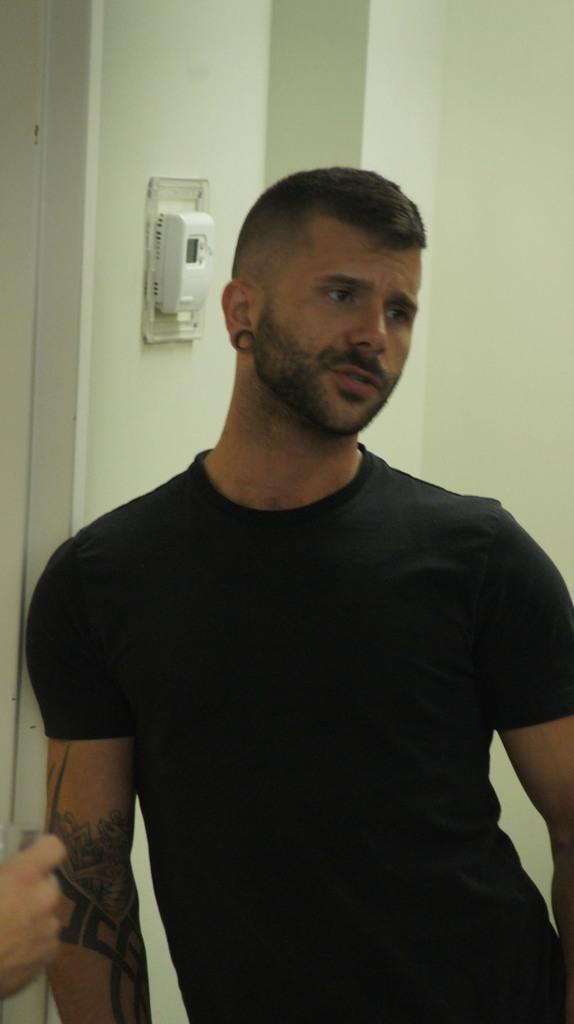What is the person in the image wearing? The person in the image is wearing a black dress. Can you describe anything else about the person in the image? There is another person's hand visible to the left of the person in the black dress. What can be seen on the wall in the background of the image? There is an electric board on the wall in the background of the image. What type of voice can be heard coming from the toy in the image? There is no toy present in the image, so it's not possible to determine what type of voice might be heard. 